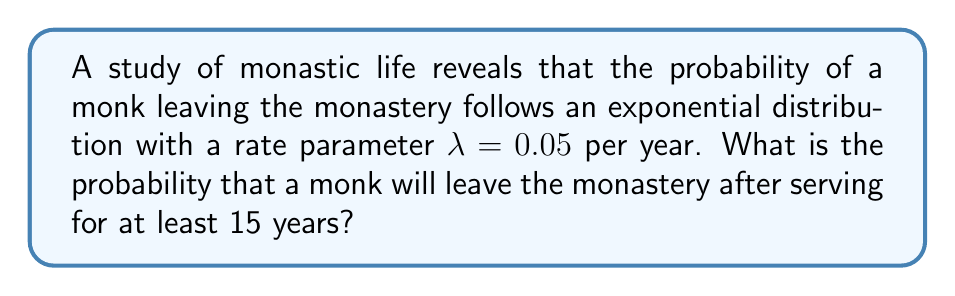Give your solution to this math problem. To solve this problem, we need to use the survival function of the exponential distribution. The steps are as follows:

1) The probability density function of an exponential distribution is:
   $$f(x) = \lambda e^{-\lambda x}$$

2) The cumulative distribution function (CDF) is:
   $$F(x) = 1 - e^{-\lambda x}$$

3) The survival function, which gives the probability of an event occurring after time x, is the complement of the CDF:
   $$S(x) = 1 - F(x) = e^{-\lambda x}$$

4) In this case, we want the probability of a monk staying for at least 15 years, so we use x = 15 and $\lambda = 0.05$:
   $$S(15) = e^{-0.05 * 15}$$

5) Calculate:
   $$S(15) = e^{-0.75} \approx 0.4724$$

6) Therefore, the probability of a monk staying for at least 15 years is about 0.4724, or 47.24%.

7) The probability of leaving after serving at least 15 years is the complement of this:
   $$P(\text{leaving after 15 years}) = 1 - S(15) = 1 - 0.4724 \approx 0.5276$$
Answer: $0.5276$ or $52.76\%$ 